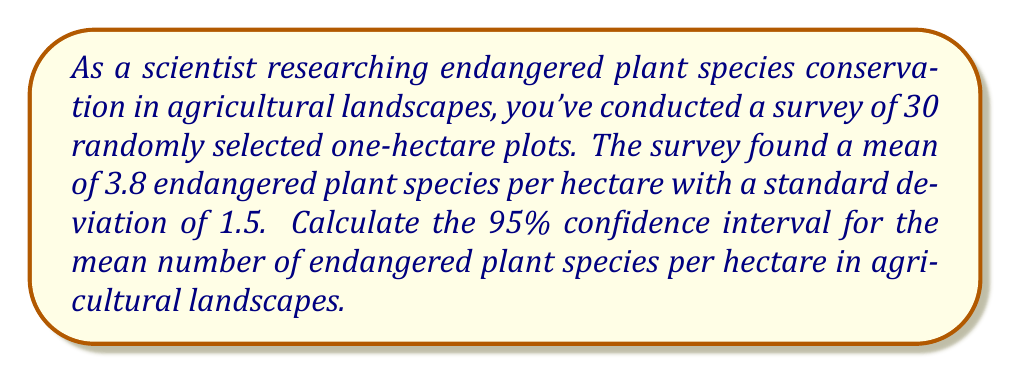Provide a solution to this math problem. To calculate the 95% confidence interval for the mean, we'll use the formula:

$$\text{CI} = \bar{x} \pm t_{\alpha/2, df} \cdot \frac{s}{\sqrt{n}}$$

Where:
$\bar{x}$ = sample mean
$t_{\alpha/2, df}$ = t-value for 95% confidence level with (n-1) degrees of freedom
$s$ = sample standard deviation
$n$ = sample size

Given:
$\bar{x} = 3.8$
$s = 1.5$
$n = 30$
Confidence level = 95%

Steps:
1) Degrees of freedom (df) = n - 1 = 30 - 1 = 29

2) For a 95% confidence level and 29 df, the t-value is approximately 2.045 (from t-table)

3) Standard error of the mean (SEM):
   $$\text{SEM} = \frac{s}{\sqrt{n}} = \frac{1.5}{\sqrt{30}} = 0.2739$$

4) Margin of error:
   $$\text{ME} = t_{\alpha/2, df} \cdot \text{SEM} = 2.045 \cdot 0.2739 = 0.5601$$

5) Calculate the confidence interval:
   Lower bound: $3.8 - 0.5601 = 3.2399$
   Upper bound: $3.8 + 0.5601 = 4.3601$

Therefore, the 95% confidence interval is (3.2399, 4.3601).
Answer: The 95% confidence interval for the mean number of endangered plant species per hectare in agricultural landscapes is (3.24, 4.36) species per hectare. 